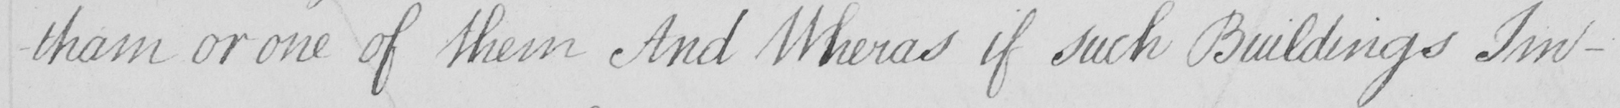What does this handwritten line say? -tham or one of them And Wheras if such Buildings Im- 